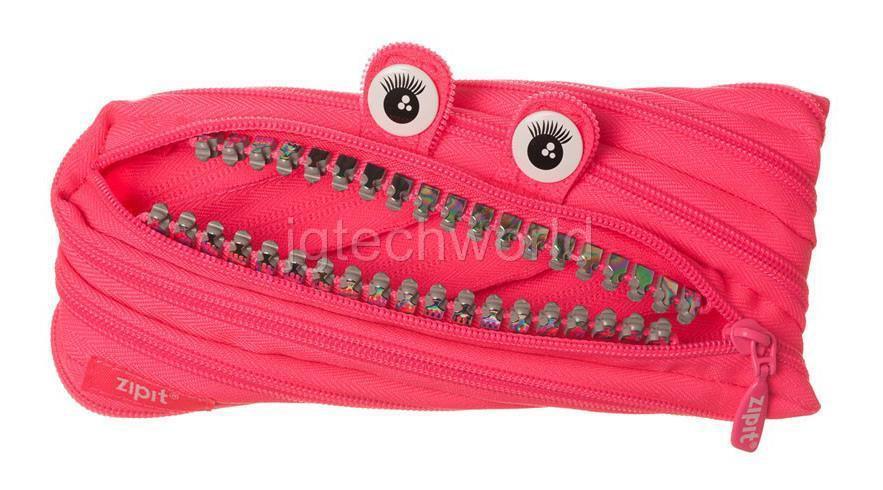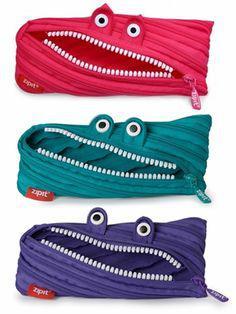The first image is the image on the left, the second image is the image on the right. Given the left and right images, does the statement "There is a single pink bag in the image on the left." hold true? Answer yes or no. Yes. 